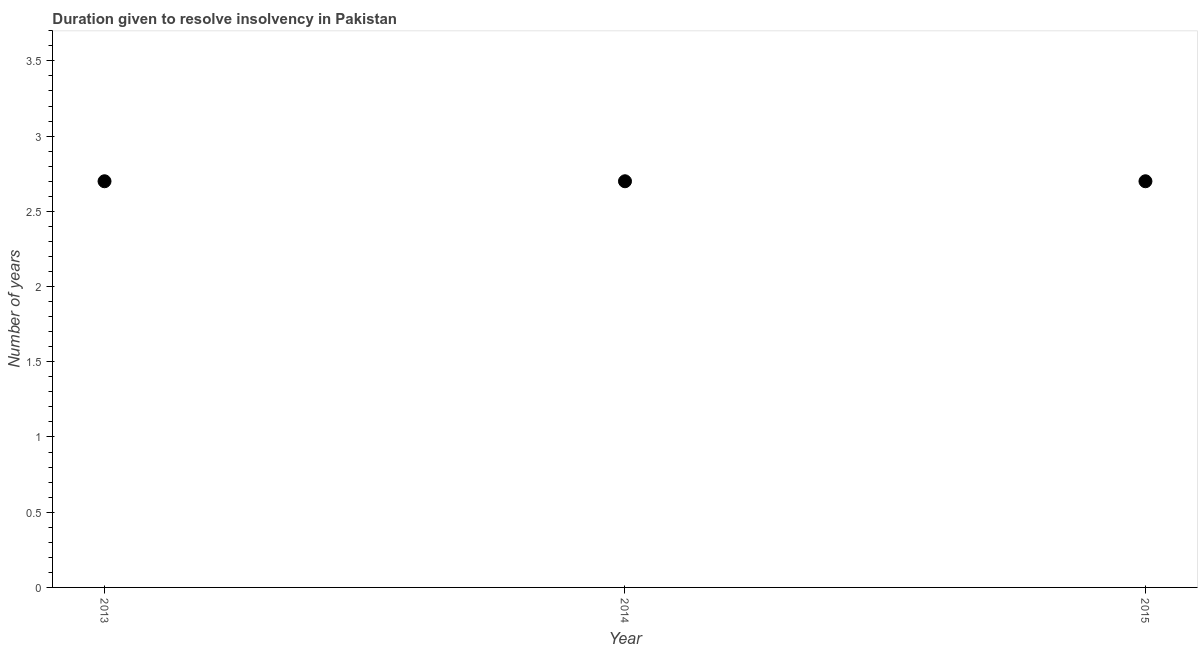What is the sum of the number of years to resolve insolvency?
Provide a short and direct response. 8.1. What is the difference between the number of years to resolve insolvency in 2014 and 2015?
Ensure brevity in your answer.  0. What is the average number of years to resolve insolvency per year?
Your answer should be compact. 2.7. In how many years, is the number of years to resolve insolvency greater than 2.5 ?
Provide a succinct answer. 3. What is the ratio of the number of years to resolve insolvency in 2013 to that in 2014?
Provide a succinct answer. 1. Is the number of years to resolve insolvency in 2013 less than that in 2014?
Ensure brevity in your answer.  No. In how many years, is the number of years to resolve insolvency greater than the average number of years to resolve insolvency taken over all years?
Provide a succinct answer. 0. How many years are there in the graph?
Ensure brevity in your answer.  3. What is the difference between two consecutive major ticks on the Y-axis?
Your response must be concise. 0.5. Does the graph contain any zero values?
Your answer should be very brief. No. Does the graph contain grids?
Provide a succinct answer. No. What is the title of the graph?
Make the answer very short. Duration given to resolve insolvency in Pakistan. What is the label or title of the X-axis?
Your answer should be compact. Year. What is the label or title of the Y-axis?
Ensure brevity in your answer.  Number of years. What is the Number of years in 2013?
Your answer should be very brief. 2.7. What is the Number of years in 2014?
Provide a succinct answer. 2.7. What is the difference between the Number of years in 2014 and 2015?
Make the answer very short. 0. 